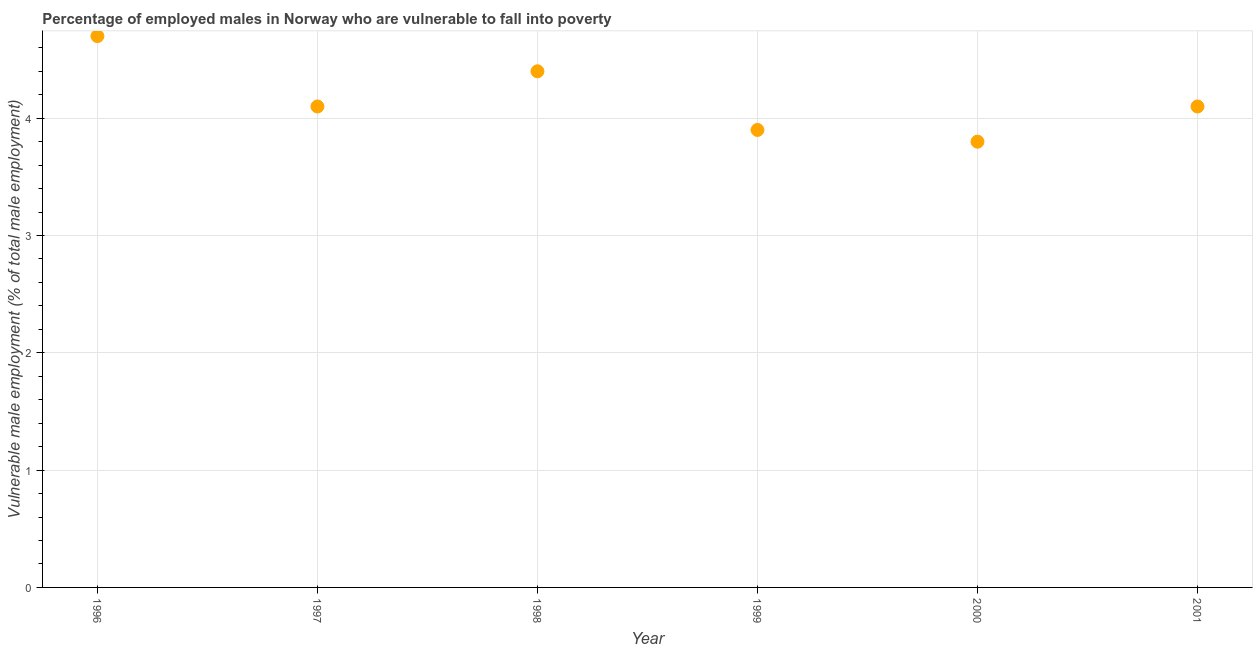What is the percentage of employed males who are vulnerable to fall into poverty in 2000?
Your answer should be very brief. 3.8. Across all years, what is the maximum percentage of employed males who are vulnerable to fall into poverty?
Keep it short and to the point. 4.7. Across all years, what is the minimum percentage of employed males who are vulnerable to fall into poverty?
Offer a very short reply. 3.8. In which year was the percentage of employed males who are vulnerable to fall into poverty maximum?
Make the answer very short. 1996. What is the sum of the percentage of employed males who are vulnerable to fall into poverty?
Your answer should be compact. 25. What is the difference between the percentage of employed males who are vulnerable to fall into poverty in 2000 and 2001?
Provide a succinct answer. -0.3. What is the average percentage of employed males who are vulnerable to fall into poverty per year?
Ensure brevity in your answer.  4.17. What is the median percentage of employed males who are vulnerable to fall into poverty?
Make the answer very short. 4.1. In how many years, is the percentage of employed males who are vulnerable to fall into poverty greater than 3 %?
Your response must be concise. 6. Do a majority of the years between 2001 and 2000 (inclusive) have percentage of employed males who are vulnerable to fall into poverty greater than 0.6000000000000001 %?
Provide a short and direct response. No. What is the ratio of the percentage of employed males who are vulnerable to fall into poverty in 1996 to that in 1997?
Offer a terse response. 1.15. Is the percentage of employed males who are vulnerable to fall into poverty in 1996 less than that in 2000?
Your response must be concise. No. Is the difference between the percentage of employed males who are vulnerable to fall into poverty in 1996 and 1997 greater than the difference between any two years?
Ensure brevity in your answer.  No. What is the difference between the highest and the second highest percentage of employed males who are vulnerable to fall into poverty?
Offer a terse response. 0.3. Is the sum of the percentage of employed males who are vulnerable to fall into poverty in 1998 and 2000 greater than the maximum percentage of employed males who are vulnerable to fall into poverty across all years?
Your answer should be compact. Yes. What is the difference between the highest and the lowest percentage of employed males who are vulnerable to fall into poverty?
Provide a succinct answer. 0.9. In how many years, is the percentage of employed males who are vulnerable to fall into poverty greater than the average percentage of employed males who are vulnerable to fall into poverty taken over all years?
Make the answer very short. 2. Does the percentage of employed males who are vulnerable to fall into poverty monotonically increase over the years?
Give a very brief answer. No. Does the graph contain any zero values?
Make the answer very short. No. What is the title of the graph?
Your answer should be compact. Percentage of employed males in Norway who are vulnerable to fall into poverty. What is the label or title of the X-axis?
Ensure brevity in your answer.  Year. What is the label or title of the Y-axis?
Your answer should be compact. Vulnerable male employment (% of total male employment). What is the Vulnerable male employment (% of total male employment) in 1996?
Make the answer very short. 4.7. What is the Vulnerable male employment (% of total male employment) in 1997?
Your answer should be very brief. 4.1. What is the Vulnerable male employment (% of total male employment) in 1998?
Your answer should be very brief. 4.4. What is the Vulnerable male employment (% of total male employment) in 1999?
Give a very brief answer. 3.9. What is the Vulnerable male employment (% of total male employment) in 2000?
Ensure brevity in your answer.  3.8. What is the Vulnerable male employment (% of total male employment) in 2001?
Your answer should be very brief. 4.1. What is the difference between the Vulnerable male employment (% of total male employment) in 1996 and 2000?
Keep it short and to the point. 0.9. What is the difference between the Vulnerable male employment (% of total male employment) in 1997 and 1998?
Give a very brief answer. -0.3. What is the difference between the Vulnerable male employment (% of total male employment) in 1997 and 2000?
Offer a terse response. 0.3. What is the difference between the Vulnerable male employment (% of total male employment) in 1998 and 2000?
Offer a terse response. 0.6. What is the difference between the Vulnerable male employment (% of total male employment) in 1999 and 2001?
Your answer should be compact. -0.2. What is the ratio of the Vulnerable male employment (% of total male employment) in 1996 to that in 1997?
Your response must be concise. 1.15. What is the ratio of the Vulnerable male employment (% of total male employment) in 1996 to that in 1998?
Offer a terse response. 1.07. What is the ratio of the Vulnerable male employment (% of total male employment) in 1996 to that in 1999?
Keep it short and to the point. 1.21. What is the ratio of the Vulnerable male employment (% of total male employment) in 1996 to that in 2000?
Your answer should be compact. 1.24. What is the ratio of the Vulnerable male employment (% of total male employment) in 1996 to that in 2001?
Make the answer very short. 1.15. What is the ratio of the Vulnerable male employment (% of total male employment) in 1997 to that in 1998?
Make the answer very short. 0.93. What is the ratio of the Vulnerable male employment (% of total male employment) in 1997 to that in 1999?
Your response must be concise. 1.05. What is the ratio of the Vulnerable male employment (% of total male employment) in 1997 to that in 2000?
Give a very brief answer. 1.08. What is the ratio of the Vulnerable male employment (% of total male employment) in 1998 to that in 1999?
Give a very brief answer. 1.13. What is the ratio of the Vulnerable male employment (% of total male employment) in 1998 to that in 2000?
Provide a succinct answer. 1.16. What is the ratio of the Vulnerable male employment (% of total male employment) in 1998 to that in 2001?
Provide a succinct answer. 1.07. What is the ratio of the Vulnerable male employment (% of total male employment) in 1999 to that in 2000?
Make the answer very short. 1.03. What is the ratio of the Vulnerable male employment (% of total male employment) in 1999 to that in 2001?
Your answer should be very brief. 0.95. What is the ratio of the Vulnerable male employment (% of total male employment) in 2000 to that in 2001?
Your answer should be very brief. 0.93. 